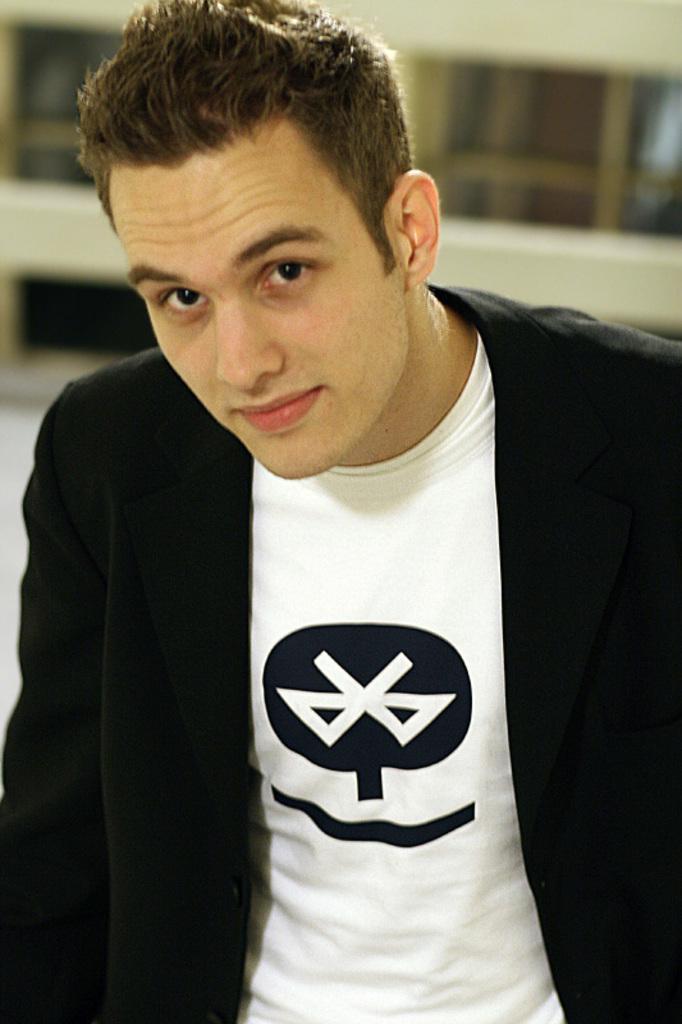How would you summarize this image in a sentence or two? In this image we can see a man. In the back we can see a building and it is blurry. 